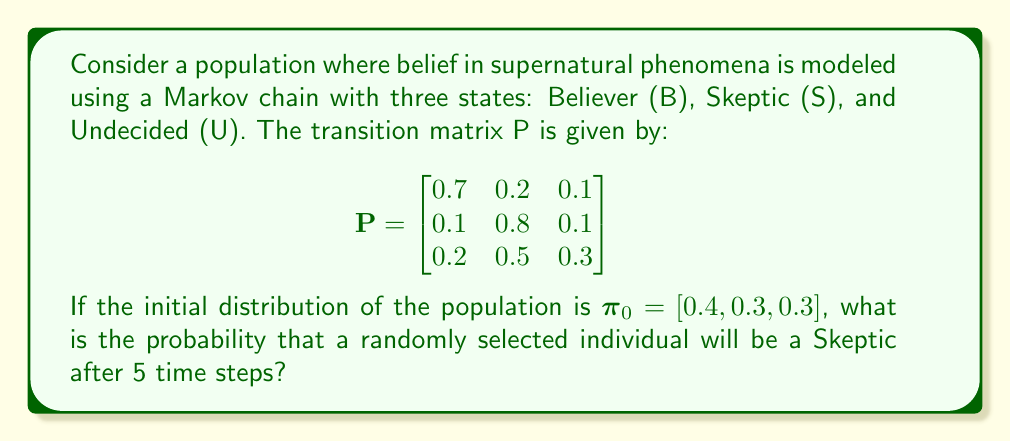Solve this math problem. To solve this problem, we need to calculate the distribution of the population after 5 time steps using the given transition matrix and initial distribution. We'll follow these steps:

1) The distribution after n time steps is given by $\pi_n = \pi_0 P^n$.

2) We need to calculate $P^5$. We can do this by multiplying P by itself 5 times:

   $P^5 = P \times P \times P \times P \times P$

3) Using a calculator or computer software, we find:

   $$P^5 \approx \begin{bmatrix}
   0.3680 & 0.5088 & 0.1232 \\
   0.3072 & 0.5824 & 0.1104 \\
   0.3376 & 0.5456 & 0.1168
   \end{bmatrix}$$

4) Now, we multiply $\pi_0$ by $P^5$:

   $\pi_5 = \pi_0 P^5 = [0.4, 0.3, 0.3] \times \begin{bmatrix}
   0.3680 & 0.5088 & 0.1232 \\
   0.3072 & 0.5824 & 0.1104 \\
   0.3376 & 0.5456 & 0.1168
   \end{bmatrix}$

5) Performing this matrix multiplication:

   $\pi_5 = [0.3440, 0.5456, 0.1168]$

6) The probability of being a Skeptic after 5 time steps is the second element of $\pi_5$, which is approximately 0.5456 or 54.56%.

This result shows that even with a significant initial belief in supernatural phenomena, the model predicts a shift towards skepticism over time, aligning with the persona's view that belief in supernatural phenomena tends to decay.
Answer: 0.5456 